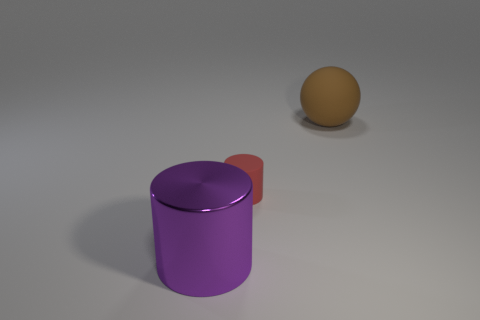The big object that is to the left of the big thing behind the red matte thing is what shape?
Your answer should be compact. Cylinder. Do the tiny red rubber object and the large purple shiny object have the same shape?
Provide a short and direct response. Yes. There is a thing on the left side of the cylinder behind the purple cylinder; how many small red matte cylinders are to the left of it?
Keep it short and to the point. 0. There is a object that is the same material as the sphere; what shape is it?
Offer a terse response. Cylinder. What material is the large thing that is on the left side of the thing that is behind the cylinder behind the shiny cylinder?
Provide a short and direct response. Metal. How many things are either objects that are in front of the red rubber cylinder or large metal objects?
Your answer should be very brief. 1. How many other things are there of the same shape as the brown object?
Offer a very short reply. 0. Is the number of red rubber things in front of the brown sphere greater than the number of cyan cubes?
Provide a short and direct response. Yes. What size is the other metal thing that is the same shape as the tiny thing?
Your answer should be compact. Large. Is there anything else that has the same material as the purple cylinder?
Your answer should be very brief. No. 